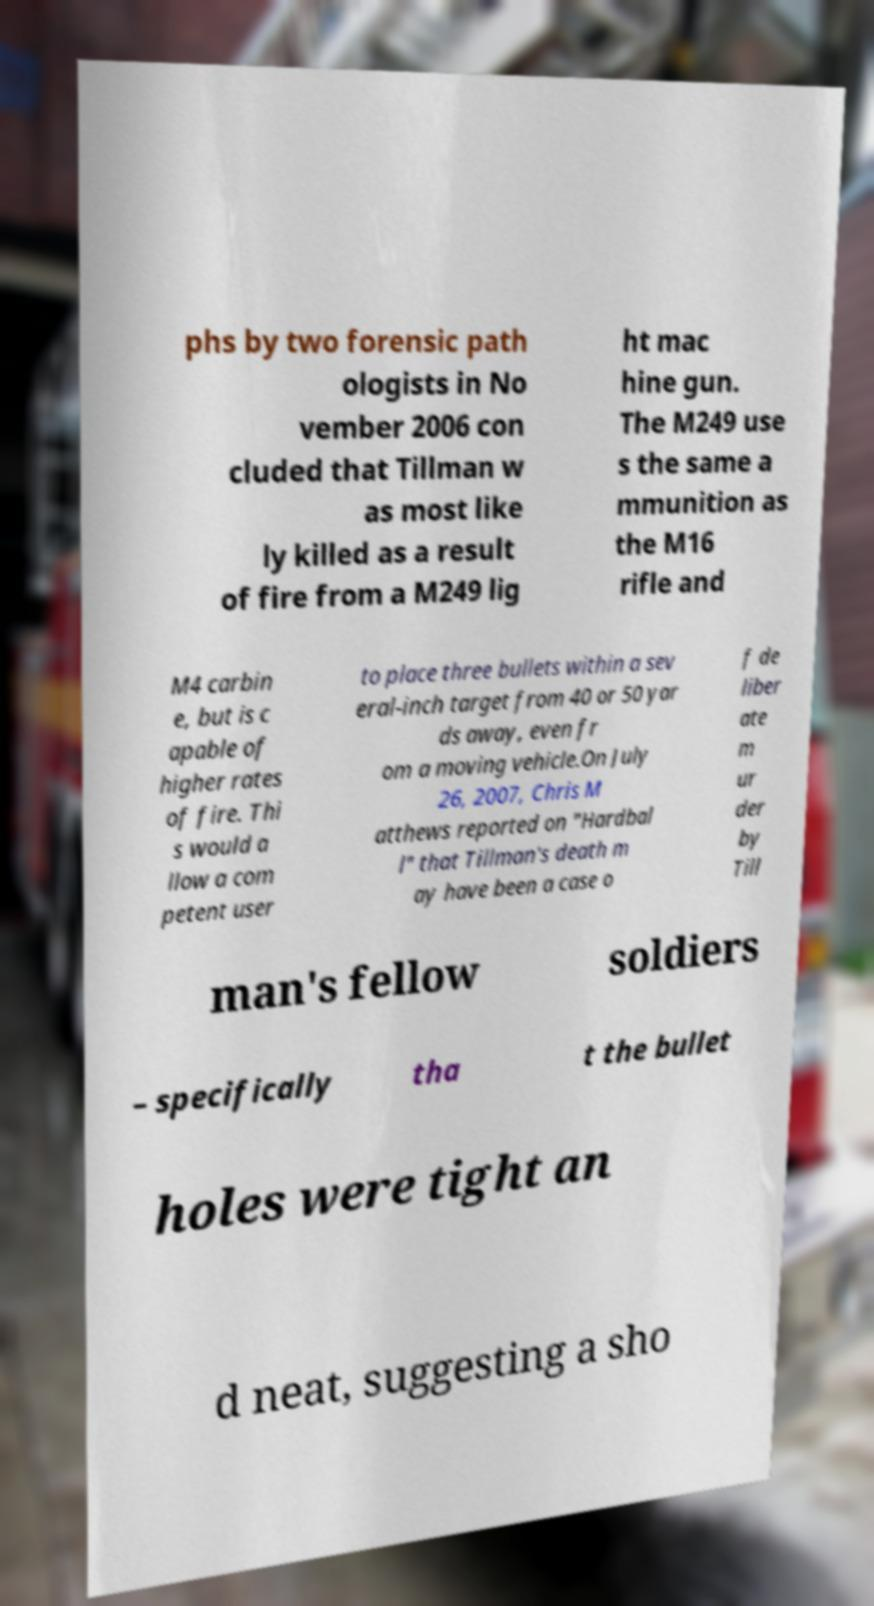There's text embedded in this image that I need extracted. Can you transcribe it verbatim? phs by two forensic path ologists in No vember 2006 con cluded that Tillman w as most like ly killed as a result of fire from a M249 lig ht mac hine gun. The M249 use s the same a mmunition as the M16 rifle and M4 carbin e, but is c apable of higher rates of fire. Thi s would a llow a com petent user to place three bullets within a sev eral-inch target from 40 or 50 yar ds away, even fr om a moving vehicle.On July 26, 2007, Chris M atthews reported on "Hardbal l" that Tillman's death m ay have been a case o f de liber ate m ur der by Till man's fellow soldiers – specifically tha t the bullet holes were tight an d neat, suggesting a sho 